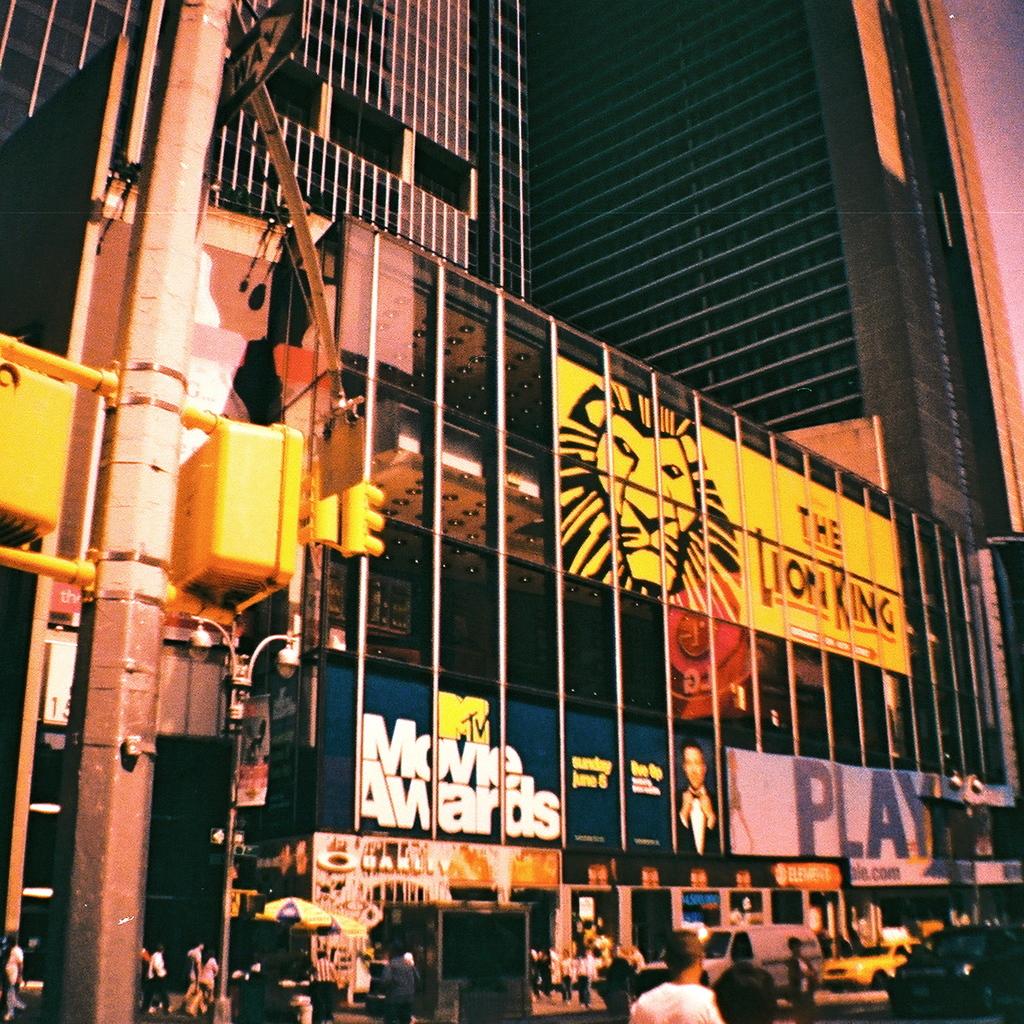What play is being advertised in the yellow sign?
Keep it short and to the point. The lion king. What broadway show is being advertised?
Your answer should be very brief. The lion king. 